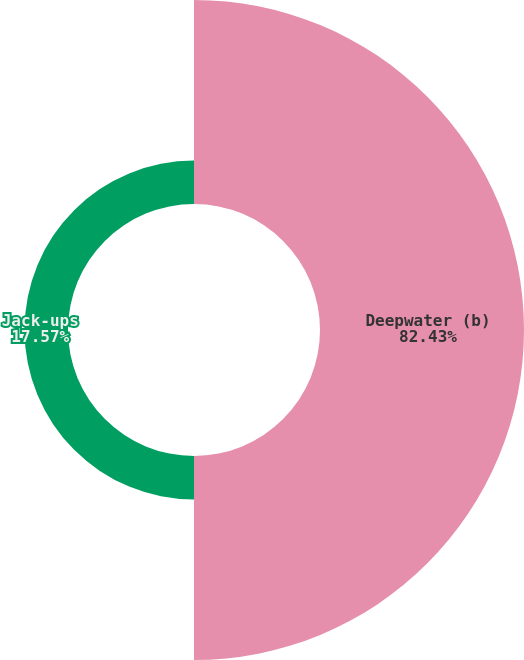<chart> <loc_0><loc_0><loc_500><loc_500><pie_chart><fcel>Deepwater (b)<fcel>Jack-ups<nl><fcel>82.43%<fcel>17.57%<nl></chart> 